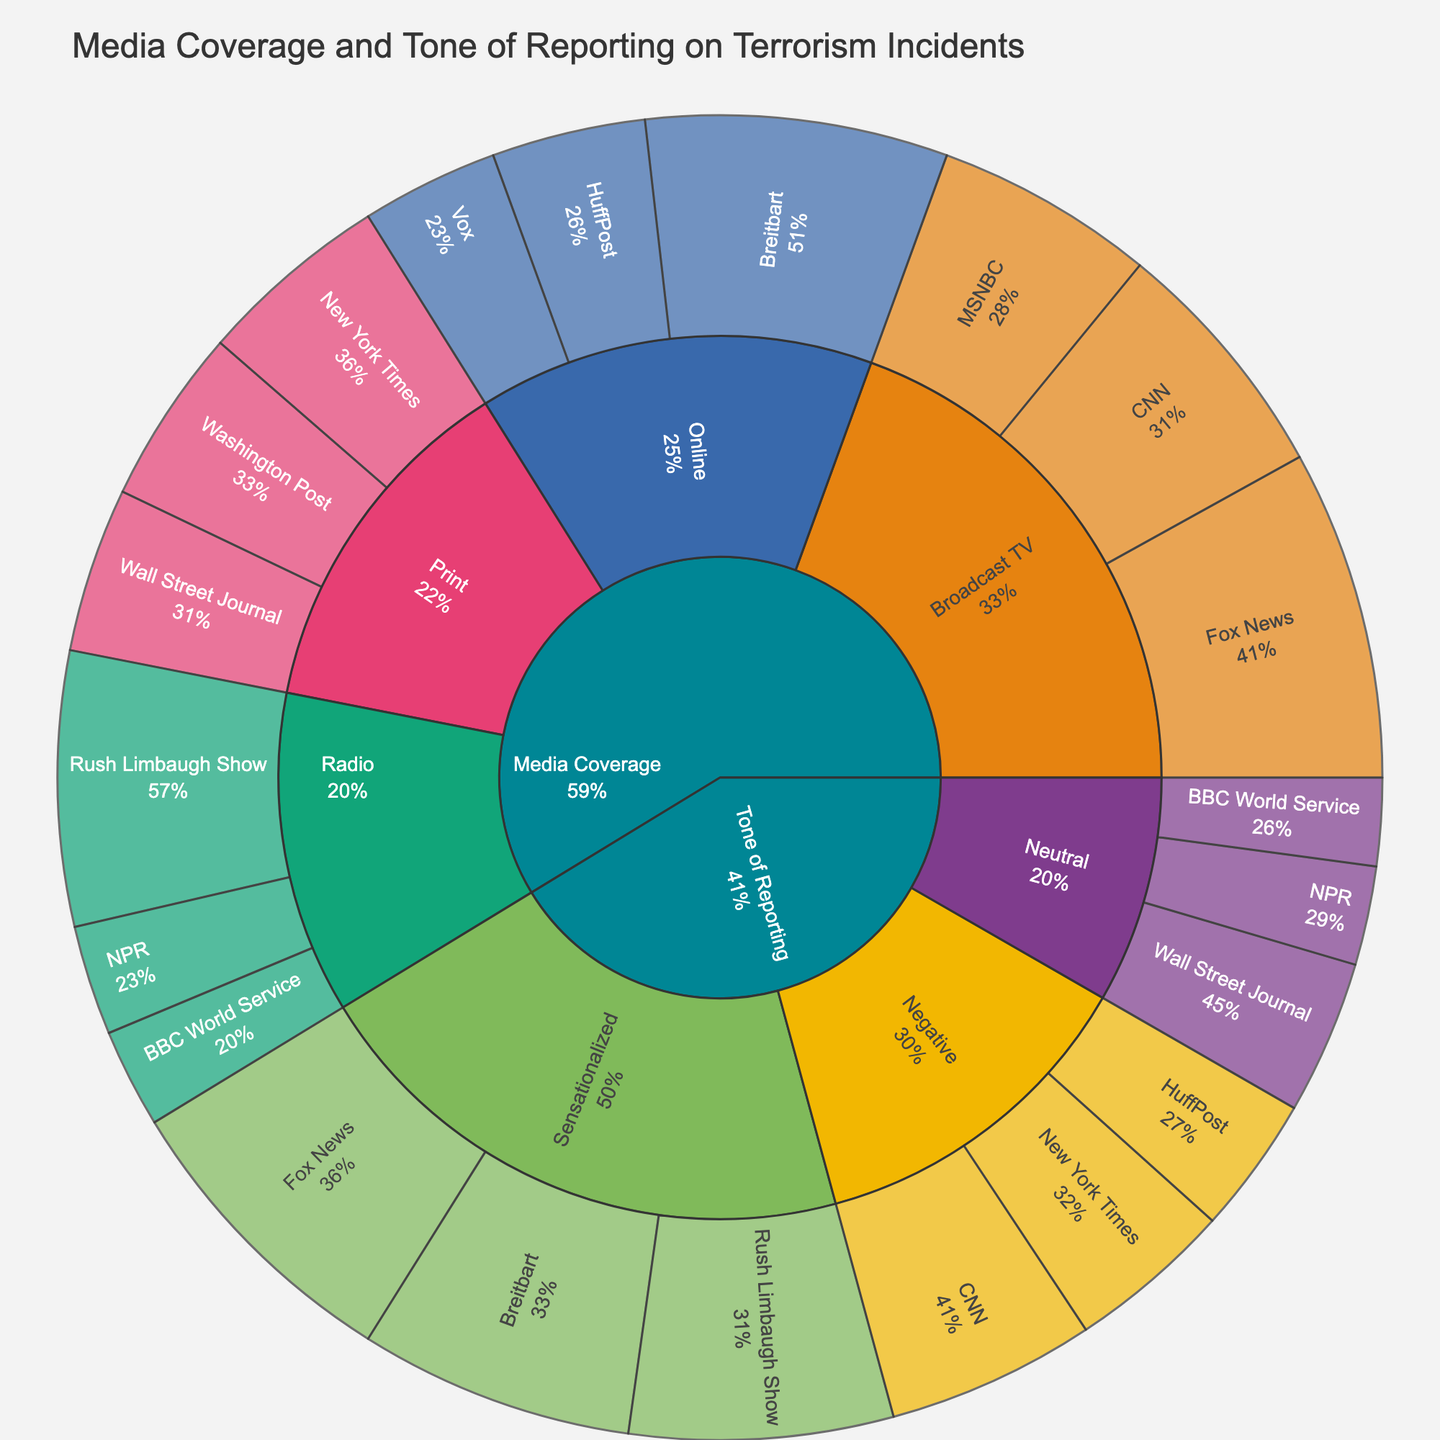What category has the highest media coverage? The overall category with the highest value encompasses all media outlet types combined, where we add up the values. For Broadcast TV: (45+60+40) = 145; for Print: (35+30+32) = 97; for Online: (55+28+25) = 108; for Radio: (20+50+18) = 88. Broadcast TV has the highest total value.
Answer: Broadcast TV Which subcategory under 'Negative' tone has the highest value? To find the highest value in the 'Negative' tone, we compare the subcategory values: CNN: 38, New York Times: 30, HuffPost: 25. The highest value is for CNN.
Answer: CNN How does the coverage of CNN compare between Broadcast TV and Negative tone? CNN has a value of 45 under Broadcast TV and 38 under the Negative tone. The difference is 45 - 38 = 7. CNN has higher coverage under Broadcast TV.
Answer: Broadcast TV is higher Which media outlet in Print has the lowest coverage? Among the Print media outlets, New York Times: 35, Wall Street Journal: 30, Washington Post: 32. The Wall Street Journal has the lowest value.
Answer: Wall Street Journal What is the percentage of Breitbart's coverage compared to the total coverage for Online media? Breitbart's value is 55. The total for Online media is 55 + 28 + 25 = 108. The percentage is (55 / 108) * 100 ≈ 50.9%.
Answer: ~50.9% What is the total value for Neutral tone reporting? Add the values for Neutral tone: NPR: 18, Wall Street Journal: 28, BBC World Service: 16. The total is 18 + 28 + 16 = 62.
Answer: 62 Which has more sensationalized coverage: Fox News or Breitbart? Fox News under Sensationalized has a value of 55, and Breitbart under Sensationalized has a value of 50. Fox News has more sensationalized coverage.
Answer: Fox News How much higher is Fox News' value compared to Rush Limbaugh Show in Broadcast TV? Fox News' value in Broadcast TV is 60, and Rush Limbaugh Show in Radio is 50. The difference is 60 - 50 = 10.
Answer: 10 higher Which media outlet has the least coverage in the entire dataset? The media outlets and their values are: CNN: 45, Fox News: 60, MSNBC: 40, New York Times: 35, Wall Street Journal: 30, Washington Post: 32, Breitbart: 55, HuffPost: 28, Vox: 25, NPR: 20, Rush Limbaugh Show: 50, BBC World Service: 18. The lowest value is BBC World Service with 18.
Answer: BBC World Service 